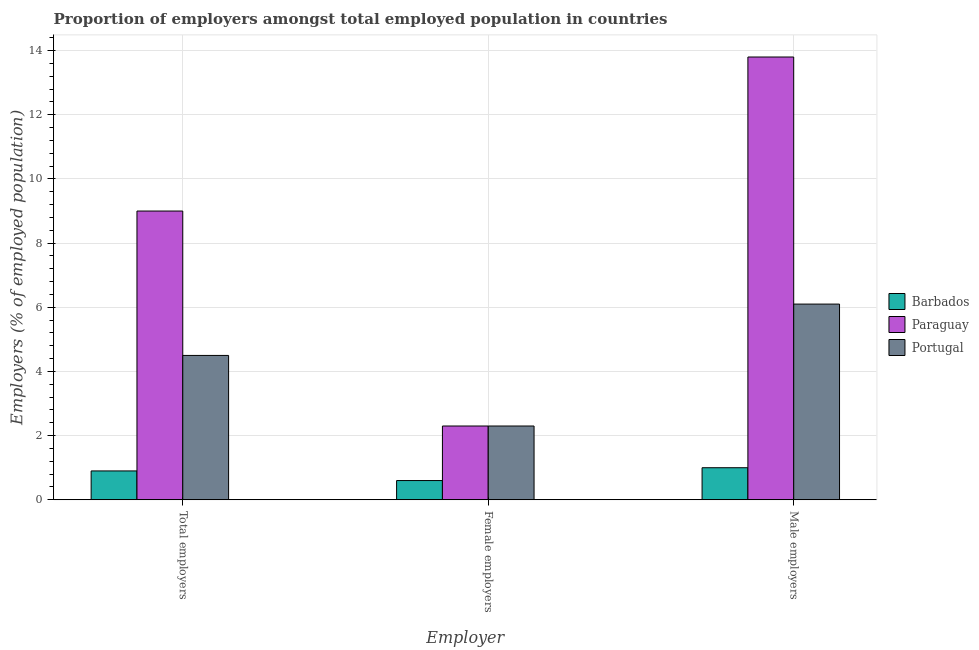How many groups of bars are there?
Provide a short and direct response. 3. Are the number of bars per tick equal to the number of legend labels?
Provide a succinct answer. Yes. How many bars are there on the 1st tick from the left?
Give a very brief answer. 3. How many bars are there on the 1st tick from the right?
Make the answer very short. 3. What is the label of the 2nd group of bars from the left?
Keep it short and to the point. Female employers. What is the percentage of female employers in Paraguay?
Provide a short and direct response. 2.3. Across all countries, what is the maximum percentage of female employers?
Offer a very short reply. 2.3. Across all countries, what is the minimum percentage of male employers?
Your answer should be very brief. 1. In which country was the percentage of female employers maximum?
Provide a succinct answer. Paraguay. In which country was the percentage of male employers minimum?
Give a very brief answer. Barbados. What is the total percentage of male employers in the graph?
Your response must be concise. 20.9. What is the difference between the percentage of female employers in Barbados and that in Portugal?
Offer a terse response. -1.7. What is the difference between the percentage of total employers in Barbados and the percentage of female employers in Portugal?
Make the answer very short. -1.4. What is the average percentage of female employers per country?
Your answer should be compact. 1.73. What is the difference between the percentage of male employers and percentage of female employers in Barbados?
Provide a succinct answer. 0.4. In how many countries, is the percentage of female employers greater than 11.6 %?
Provide a succinct answer. 0. What is the ratio of the percentage of female employers in Portugal to that in Barbados?
Offer a very short reply. 3.83. What is the difference between the highest and the lowest percentage of male employers?
Ensure brevity in your answer.  12.8. In how many countries, is the percentage of male employers greater than the average percentage of male employers taken over all countries?
Provide a succinct answer. 1. Is the sum of the percentage of female employers in Paraguay and Barbados greater than the maximum percentage of total employers across all countries?
Provide a succinct answer. No. What does the 1st bar from the left in Female employers represents?
Keep it short and to the point. Barbados. What does the 2nd bar from the right in Female employers represents?
Make the answer very short. Paraguay. Are all the bars in the graph horizontal?
Make the answer very short. No. How many countries are there in the graph?
Make the answer very short. 3. Does the graph contain grids?
Offer a terse response. Yes. Where does the legend appear in the graph?
Offer a terse response. Center right. How are the legend labels stacked?
Provide a succinct answer. Vertical. What is the title of the graph?
Provide a short and direct response. Proportion of employers amongst total employed population in countries. Does "Central Europe" appear as one of the legend labels in the graph?
Your answer should be very brief. No. What is the label or title of the X-axis?
Make the answer very short. Employer. What is the label or title of the Y-axis?
Give a very brief answer. Employers (% of employed population). What is the Employers (% of employed population) in Barbados in Total employers?
Your response must be concise. 0.9. What is the Employers (% of employed population) of Barbados in Female employers?
Keep it short and to the point. 0.6. What is the Employers (% of employed population) of Paraguay in Female employers?
Make the answer very short. 2.3. What is the Employers (% of employed population) of Portugal in Female employers?
Provide a succinct answer. 2.3. What is the Employers (% of employed population) of Paraguay in Male employers?
Give a very brief answer. 13.8. What is the Employers (% of employed population) in Portugal in Male employers?
Your response must be concise. 6.1. Across all Employer, what is the maximum Employers (% of employed population) of Paraguay?
Your answer should be very brief. 13.8. Across all Employer, what is the maximum Employers (% of employed population) of Portugal?
Ensure brevity in your answer.  6.1. Across all Employer, what is the minimum Employers (% of employed population) of Barbados?
Offer a very short reply. 0.6. Across all Employer, what is the minimum Employers (% of employed population) of Paraguay?
Your answer should be compact. 2.3. Across all Employer, what is the minimum Employers (% of employed population) of Portugal?
Give a very brief answer. 2.3. What is the total Employers (% of employed population) of Paraguay in the graph?
Ensure brevity in your answer.  25.1. What is the difference between the Employers (% of employed population) of Barbados in Total employers and that in Female employers?
Provide a short and direct response. 0.3. What is the difference between the Employers (% of employed population) of Paraguay in Total employers and that in Female employers?
Your answer should be compact. 6.7. What is the difference between the Employers (% of employed population) in Barbados in Total employers and that in Male employers?
Your response must be concise. -0.1. What is the difference between the Employers (% of employed population) in Paraguay in Total employers and that in Male employers?
Your answer should be very brief. -4.8. What is the difference between the Employers (% of employed population) of Paraguay in Female employers and that in Male employers?
Your response must be concise. -11.5. What is the difference between the Employers (% of employed population) in Paraguay in Total employers and the Employers (% of employed population) in Portugal in Male employers?
Your response must be concise. 2.9. What is the difference between the Employers (% of employed population) of Barbados in Female employers and the Employers (% of employed population) of Paraguay in Male employers?
Keep it short and to the point. -13.2. What is the difference between the Employers (% of employed population) of Barbados in Female employers and the Employers (% of employed population) of Portugal in Male employers?
Your answer should be very brief. -5.5. What is the difference between the Employers (% of employed population) of Paraguay in Female employers and the Employers (% of employed population) of Portugal in Male employers?
Provide a short and direct response. -3.8. What is the average Employers (% of employed population) of Paraguay per Employer?
Provide a short and direct response. 8.37. What is the average Employers (% of employed population) in Portugal per Employer?
Keep it short and to the point. 4.3. What is the difference between the Employers (% of employed population) of Barbados and Employers (% of employed population) of Portugal in Total employers?
Provide a succinct answer. -3.6. What is the difference between the Employers (% of employed population) in Barbados and Employers (% of employed population) in Portugal in Female employers?
Provide a succinct answer. -1.7. What is the difference between the Employers (% of employed population) of Barbados and Employers (% of employed population) of Portugal in Male employers?
Your answer should be compact. -5.1. What is the ratio of the Employers (% of employed population) in Barbados in Total employers to that in Female employers?
Make the answer very short. 1.5. What is the ratio of the Employers (% of employed population) in Paraguay in Total employers to that in Female employers?
Your response must be concise. 3.91. What is the ratio of the Employers (% of employed population) in Portugal in Total employers to that in Female employers?
Keep it short and to the point. 1.96. What is the ratio of the Employers (% of employed population) in Paraguay in Total employers to that in Male employers?
Your answer should be compact. 0.65. What is the ratio of the Employers (% of employed population) in Portugal in Total employers to that in Male employers?
Keep it short and to the point. 0.74. What is the ratio of the Employers (% of employed population) in Barbados in Female employers to that in Male employers?
Provide a short and direct response. 0.6. What is the ratio of the Employers (% of employed population) of Portugal in Female employers to that in Male employers?
Your answer should be compact. 0.38. 